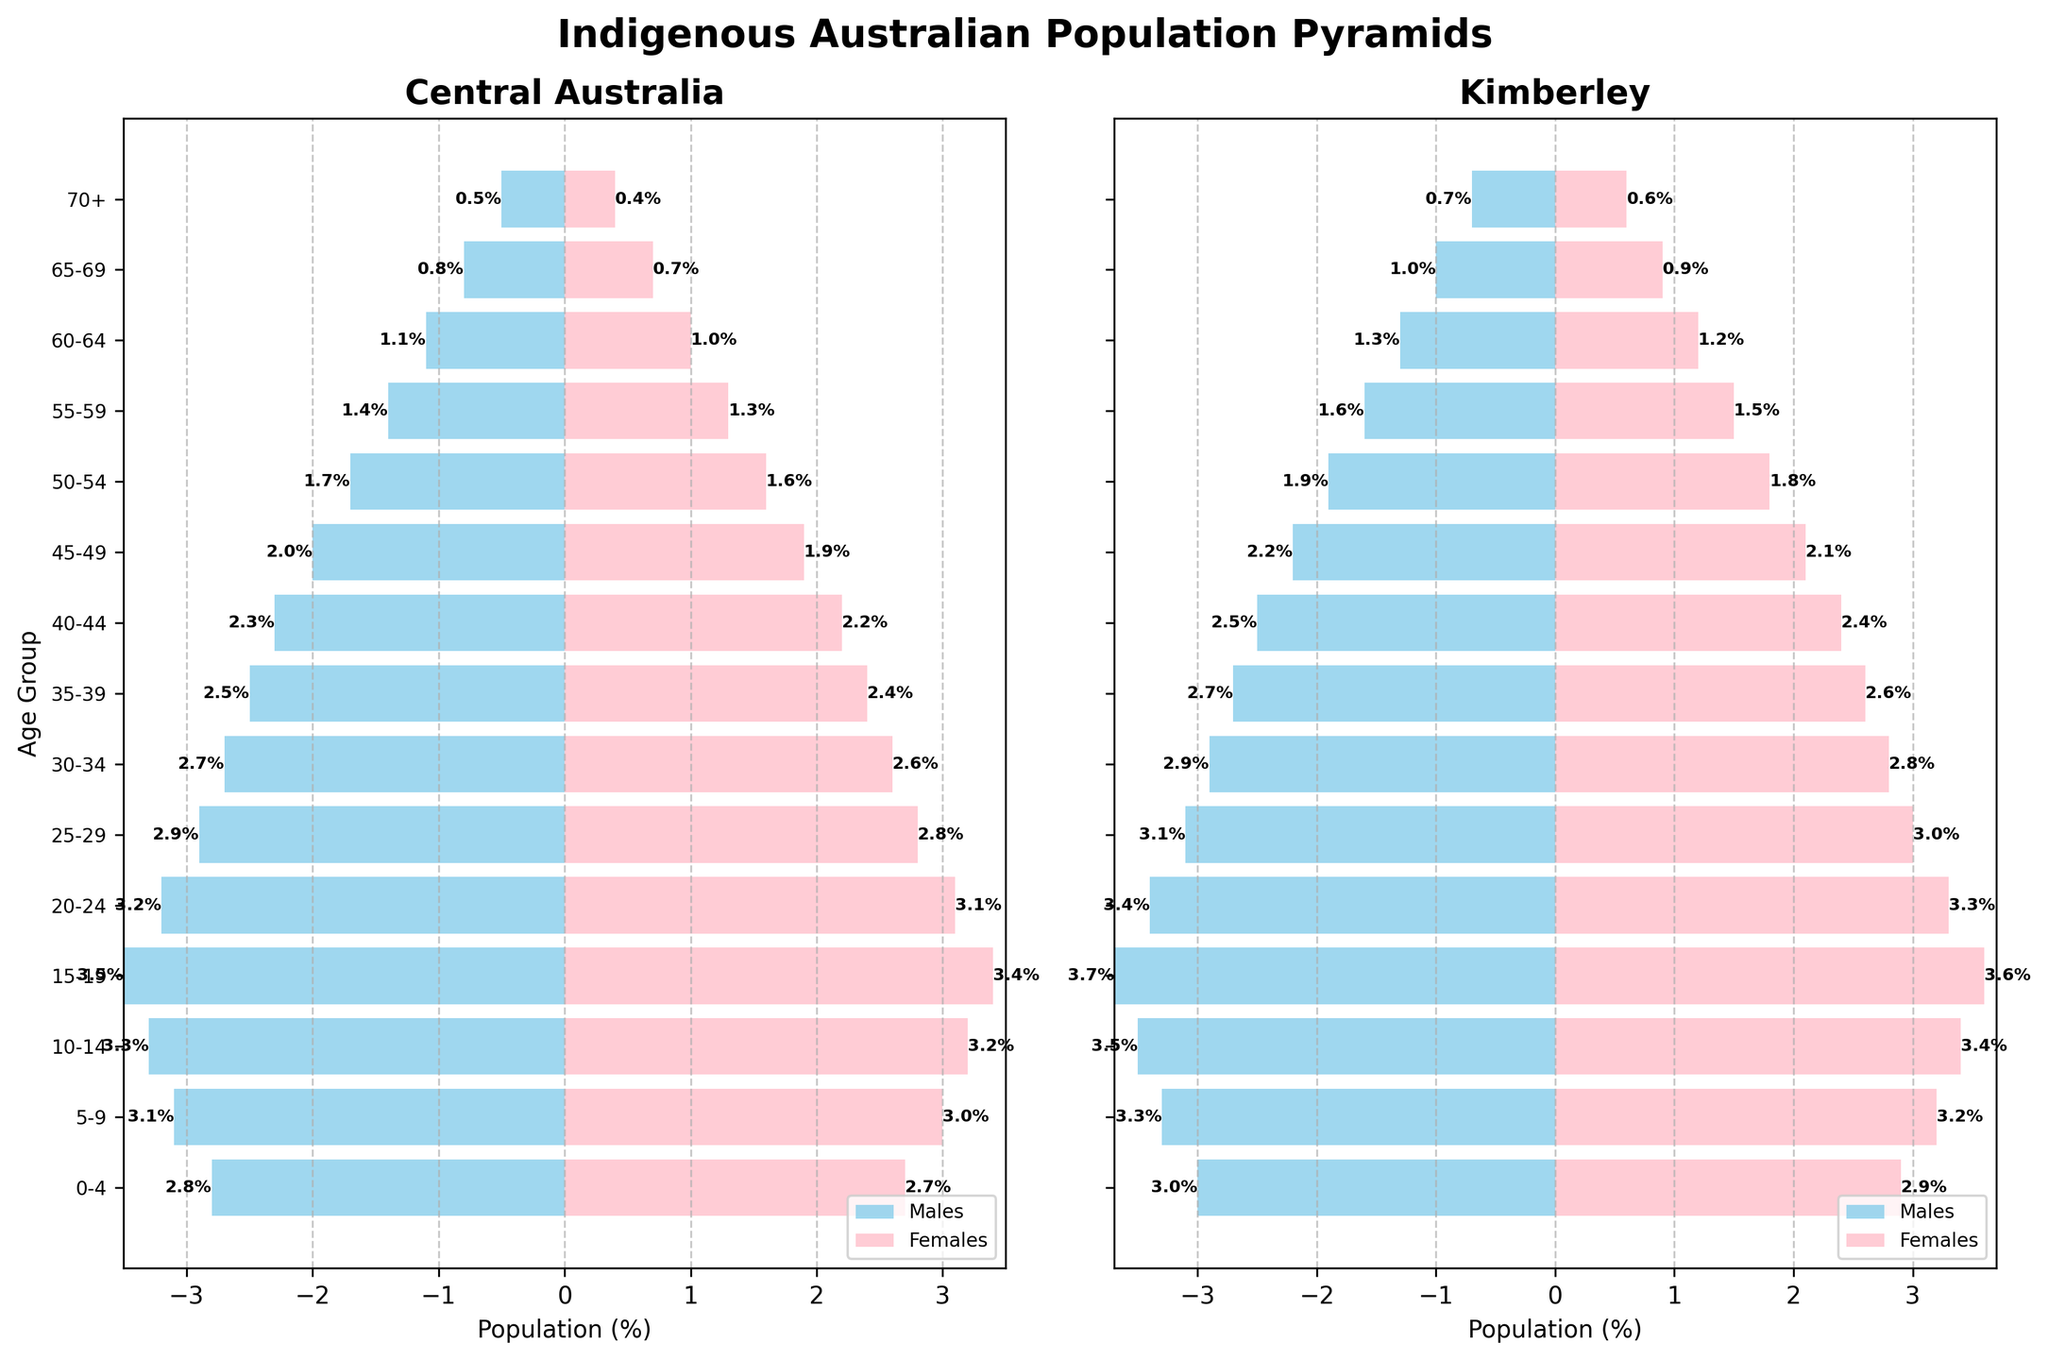Which region has a higher percentage of the male population aged 15-19? By comparing the height of the bars for the male population in the 15-19 age group, we see that Central Australia has a length of -3.5%, while Kimberley has -3.7%. Therefore, Kimberley has a higher percentage of males aged 15-19.
Answer: Kimberley What is the primary color used to represent females in both regions? The bar color used to represent the female population in both regions is pink.
Answer: Pink How does the population of females aged 0-4 in Kimberley compare with that in Central Australia? The percentage for females aged 0-4 in Kimberley is 2.9%, while in Central Australia it is 2.7%. Therefore, Kimberley has a slightly higher percentage in this age group for females.
Answer: Kimberley Is the population of males aged 70+ higher in Central Australia or Kimberley? By looking at the bars for males aged 70+, Central Australia has a bar length of -0.5%, and Kimberley has -0.7%. Therefore, Kimberley has a higher percentage of males aged 70+.
Answer: Kimberley What is the overall trend in the population distribution as the age increases in each region? Observing the bars, both regions show a decreasing trend in population percentages as age groups increase, indicating a younger population distribution.
Answer: Decreasing trend Compare the female population percentages aged 45-49 and 50-54 within Kimberley. Which group is larger? In Kimberley, the percentage for females aged 45-49 is 2.1%, and for 50-54 it is 1.8%. Thus, the 45-49 age group has a larger population.
Answer: Females aged 45-49 What age group in Central Australia shows the highest percentage of the female population? The age group 15-19 in Central Australia shows the highest percentage of females at 3.4%.
Answer: 15-19 Which age group has the smallest male population percentage in Central Australia? The age group 70+ has the smallest male population percentage in Central Australia at -0.5%.
Answer: 70+ Calculate the total percentage of the male population for the age group 25-29 across both regions. In Central Australia, the percentage for males aged 25-29 is -2.9%, and in Kimberley, it is -3.1%. Adding these values: -2.9 - 3.1 = -6.0%.
Answer: -6.0% What is the difference in the female population percentage between Central Australia and Kimberley for the age group 20-24? For females aged 20-24, Central Australia has 3.1%, and Kimberley has 3.3%. The difference is 3.3 - 3.1 = 0.2%.
Answer: 0.2% 